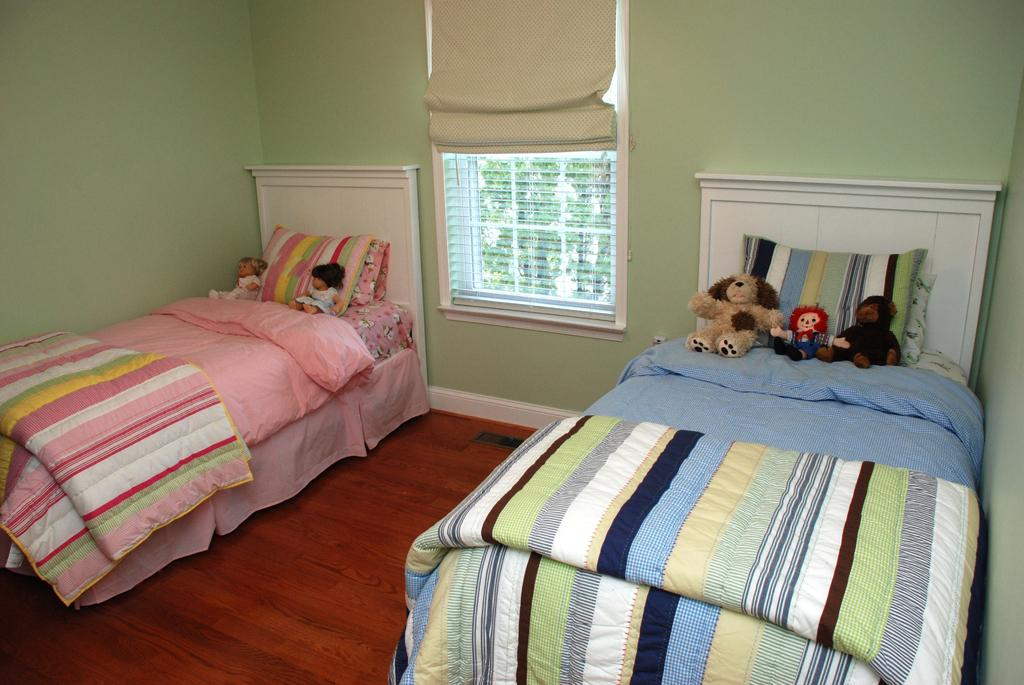How many beds are visible in the image? There are two beds in the image. What can be found on the beds? Toys and pillows are present on the beds. What is located between the two beds? There is a window between the beds. What type of rock is being used as a yoke for the selection of animals in the image? There is no rock, yoke, or selection of animals present in the image. 